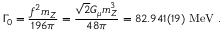Convert formula to latex. <formula><loc_0><loc_0><loc_500><loc_500>\Gamma _ { 0 } = \frac { f ^ { 2 } m _ { Z } } { 1 9 6 \pi } = \frac { \sqrt { 2 } G _ { \mu } m _ { Z } ^ { 3 } } { 4 8 \pi } = 8 2 . 9 4 1 ( 1 9 ) M e V .</formula> 